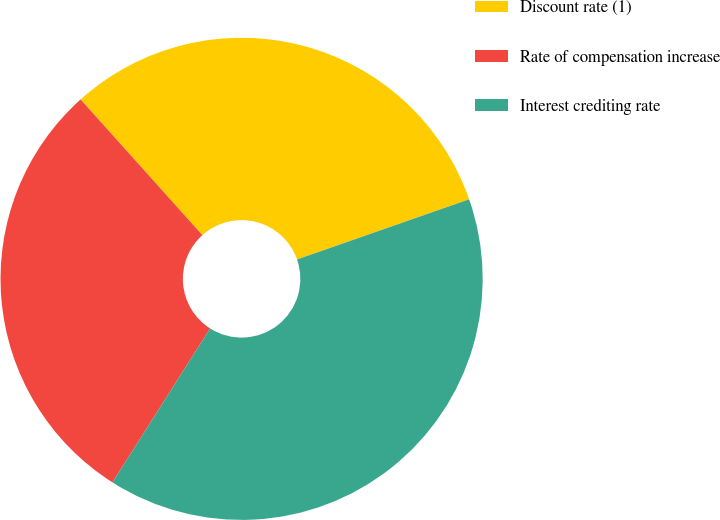Convert chart to OTSL. <chart><loc_0><loc_0><loc_500><loc_500><pie_chart><fcel>Discount rate (1)<fcel>Rate of compensation increase<fcel>Interest crediting rate<nl><fcel>31.29%<fcel>29.36%<fcel>39.35%<nl></chart> 